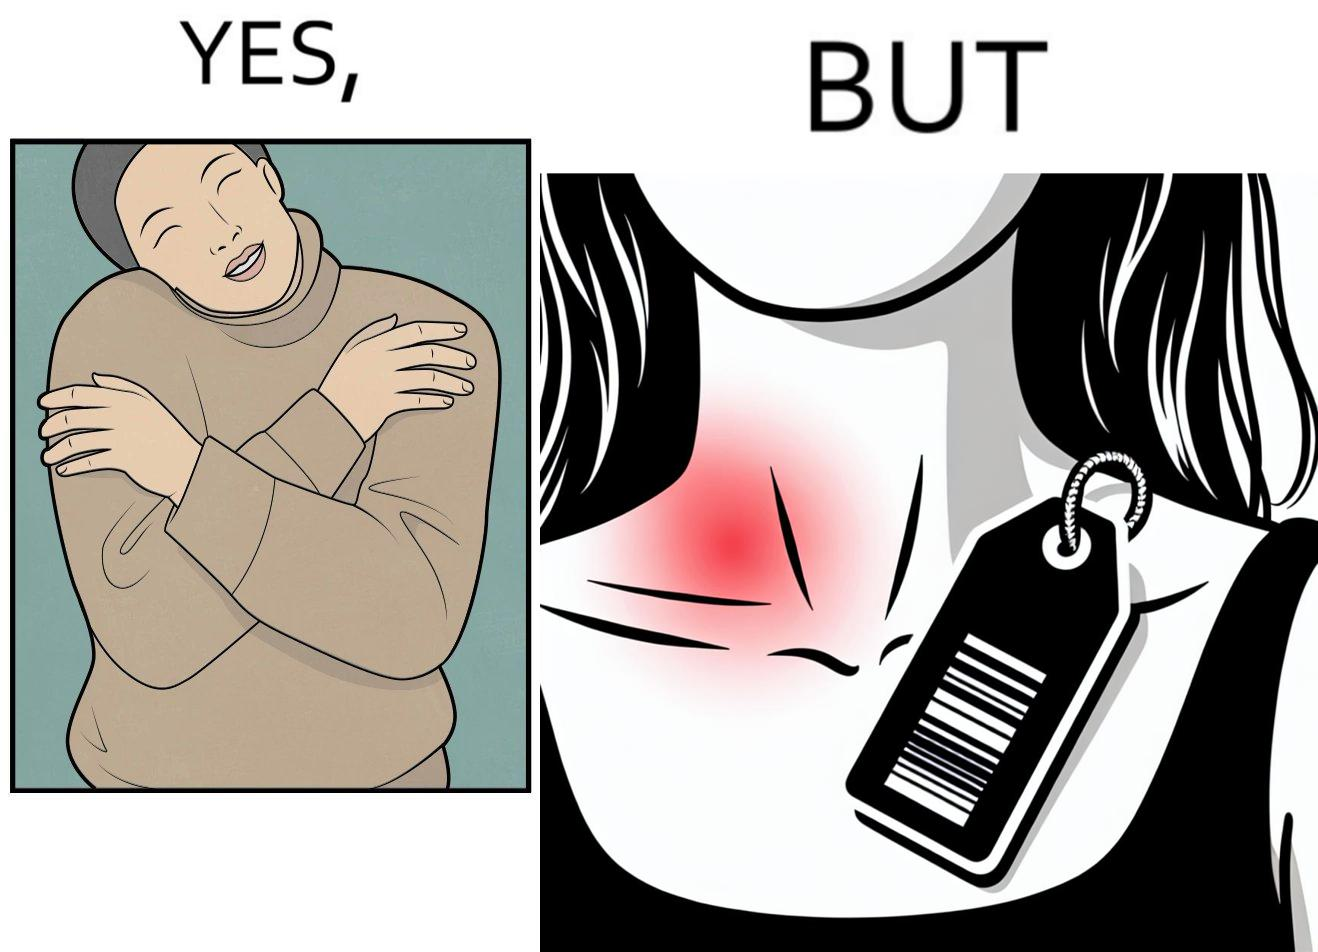Explain why this image is satirical. The images are funny since it shows how even though sweaters and other clothings provide much comfort, a tiny manufacturers tag ends up causing the user a lot of discomfort due to constant scratching 